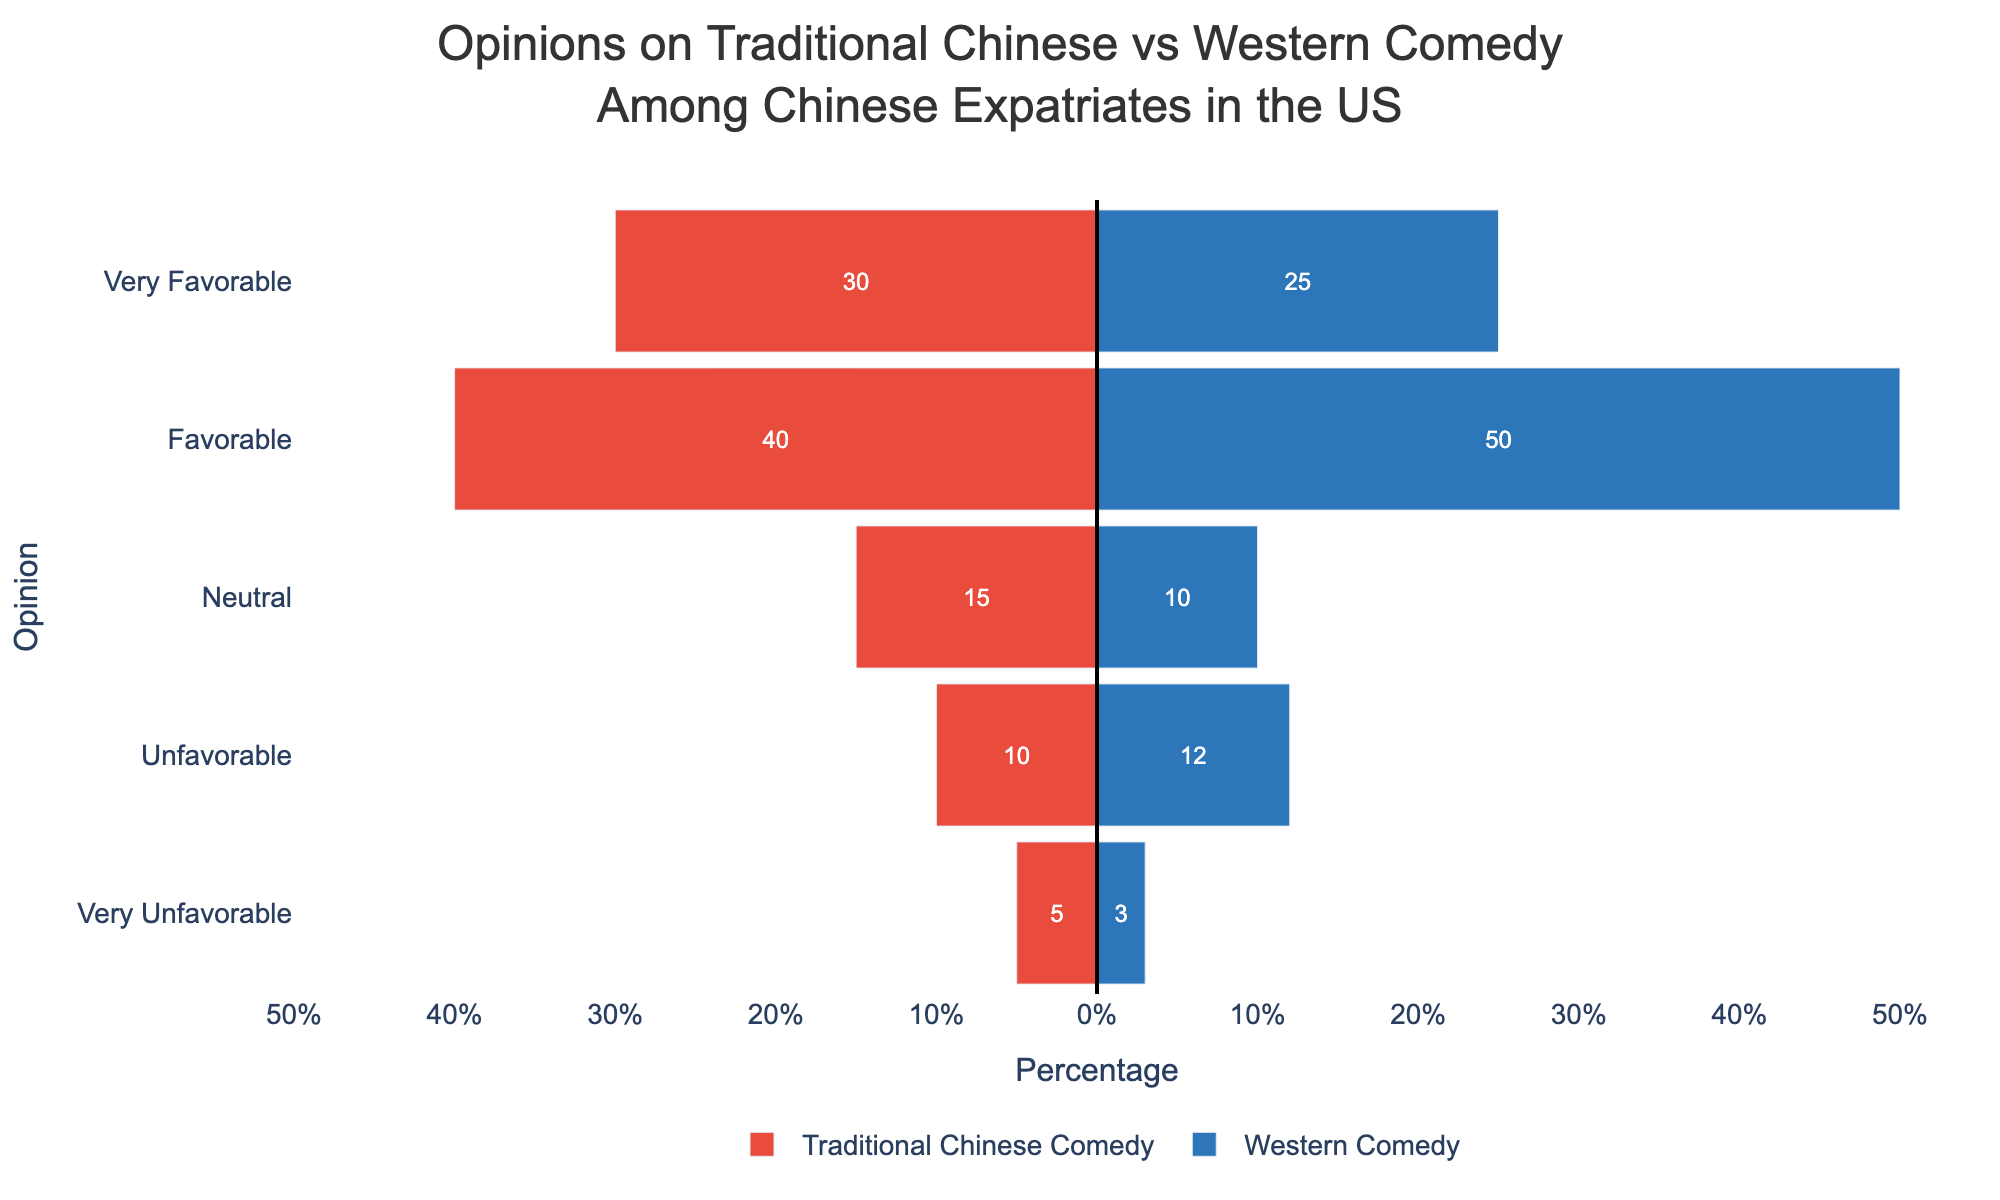What is the total number of people who have a favorable opinion of Traditional Chinese Comedy? Adding up the values for "Very Favorable" and "Favorable" categories for Traditional Chinese Comedy, we have 30 (Very Favorable) + 40 (Favorable) = 70
Answer: 70 Which comedy style has more people with a very unfavorable opinion? For the "Very Unfavorable" category, Traditional Chinese Comedy has 5, while Western Comedy has 3. Thus, Traditional Chinese Comedy has more people with a very unfavorable opinion.
Answer: Traditional Chinese Comedy What is the difference in the number of people who are neutral about Western Comedy compared to Traditional Chinese Comedy? The number of people neutral about Traditional Chinese Comedy is 15 and for Western Comedy is 10. The difference is 15 - 10 = 5.
Answer: 5 How many people overall have an unfavorable or very unfavorable opinion of Western Comedy? Adding the values in the "Unfavorable" and "Very Unfavorable" categories for Western Comedy, we have 12 (Unfavorable) + 3 (Very Unfavorable) = 15
Answer: 15 Which opinion category has the highest overall count when considering both Traditional Chinese and Western Comedy together? Summing the counts for both comedy styles in each category: Very Favorable: 30+25=55, Favorable: 40+50=90, Neutral: 15+10=25, Unfavorable: 10+12=22, Very Unfavorable: 5+3=8. The Favorable category has the highest overall count, which is 90.
Answer: Favorable How many more people have a favorable opinion of Western Comedy compared to Traditional Chinese Comedy? The number of people with a favorable opinion of Western Comedy is 50, and for Traditional Chinese Comedy, it's 40. The difference is 50 - 40 = 10.
Answer: 10 Which comedy style has more favorable opinions (both very favorable and favorable combined)? For Traditional Chinese Comedy: 30 (Very Favorable) + 40 (Favorable) = 70. For Western Comedy: 25 (Very Favorable) + 50 (Favorable) = 75. Western Comedy has more favorable opinions overall.
Answer: Western Comedy How many fewer people have a very favorable opinion of Western Comedy compared to Traditional Chinese Comedy? The number of people with a very favorable opinion of Traditional Chinese Comedy is 30, for Western Comedy it is 25. The difference is 30 - 25 = 5.
Answer: 5 